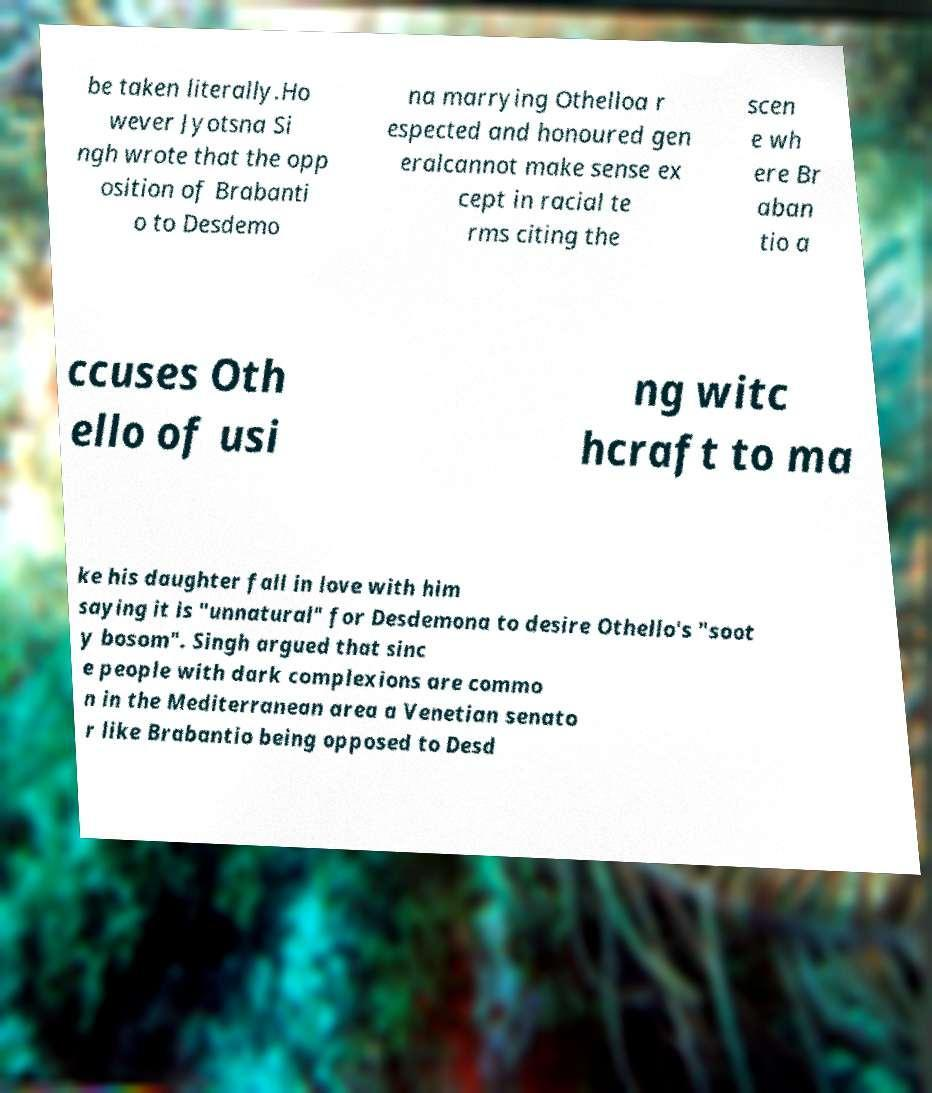For documentation purposes, I need the text within this image transcribed. Could you provide that? be taken literally.Ho wever Jyotsna Si ngh wrote that the opp osition of Brabanti o to Desdemo na marrying Othelloa r espected and honoured gen eralcannot make sense ex cept in racial te rms citing the scen e wh ere Br aban tio a ccuses Oth ello of usi ng witc hcraft to ma ke his daughter fall in love with him saying it is "unnatural" for Desdemona to desire Othello's "soot y bosom". Singh argued that sinc e people with dark complexions are commo n in the Mediterranean area a Venetian senato r like Brabantio being opposed to Desd 